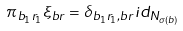<formula> <loc_0><loc_0><loc_500><loc_500>\pi _ { b _ { 1 } r _ { 1 } } \xi _ { b r } = \delta _ { b _ { 1 } r _ { 1 } , b r } i d _ { N _ { \sigma ( b ) } }</formula> 